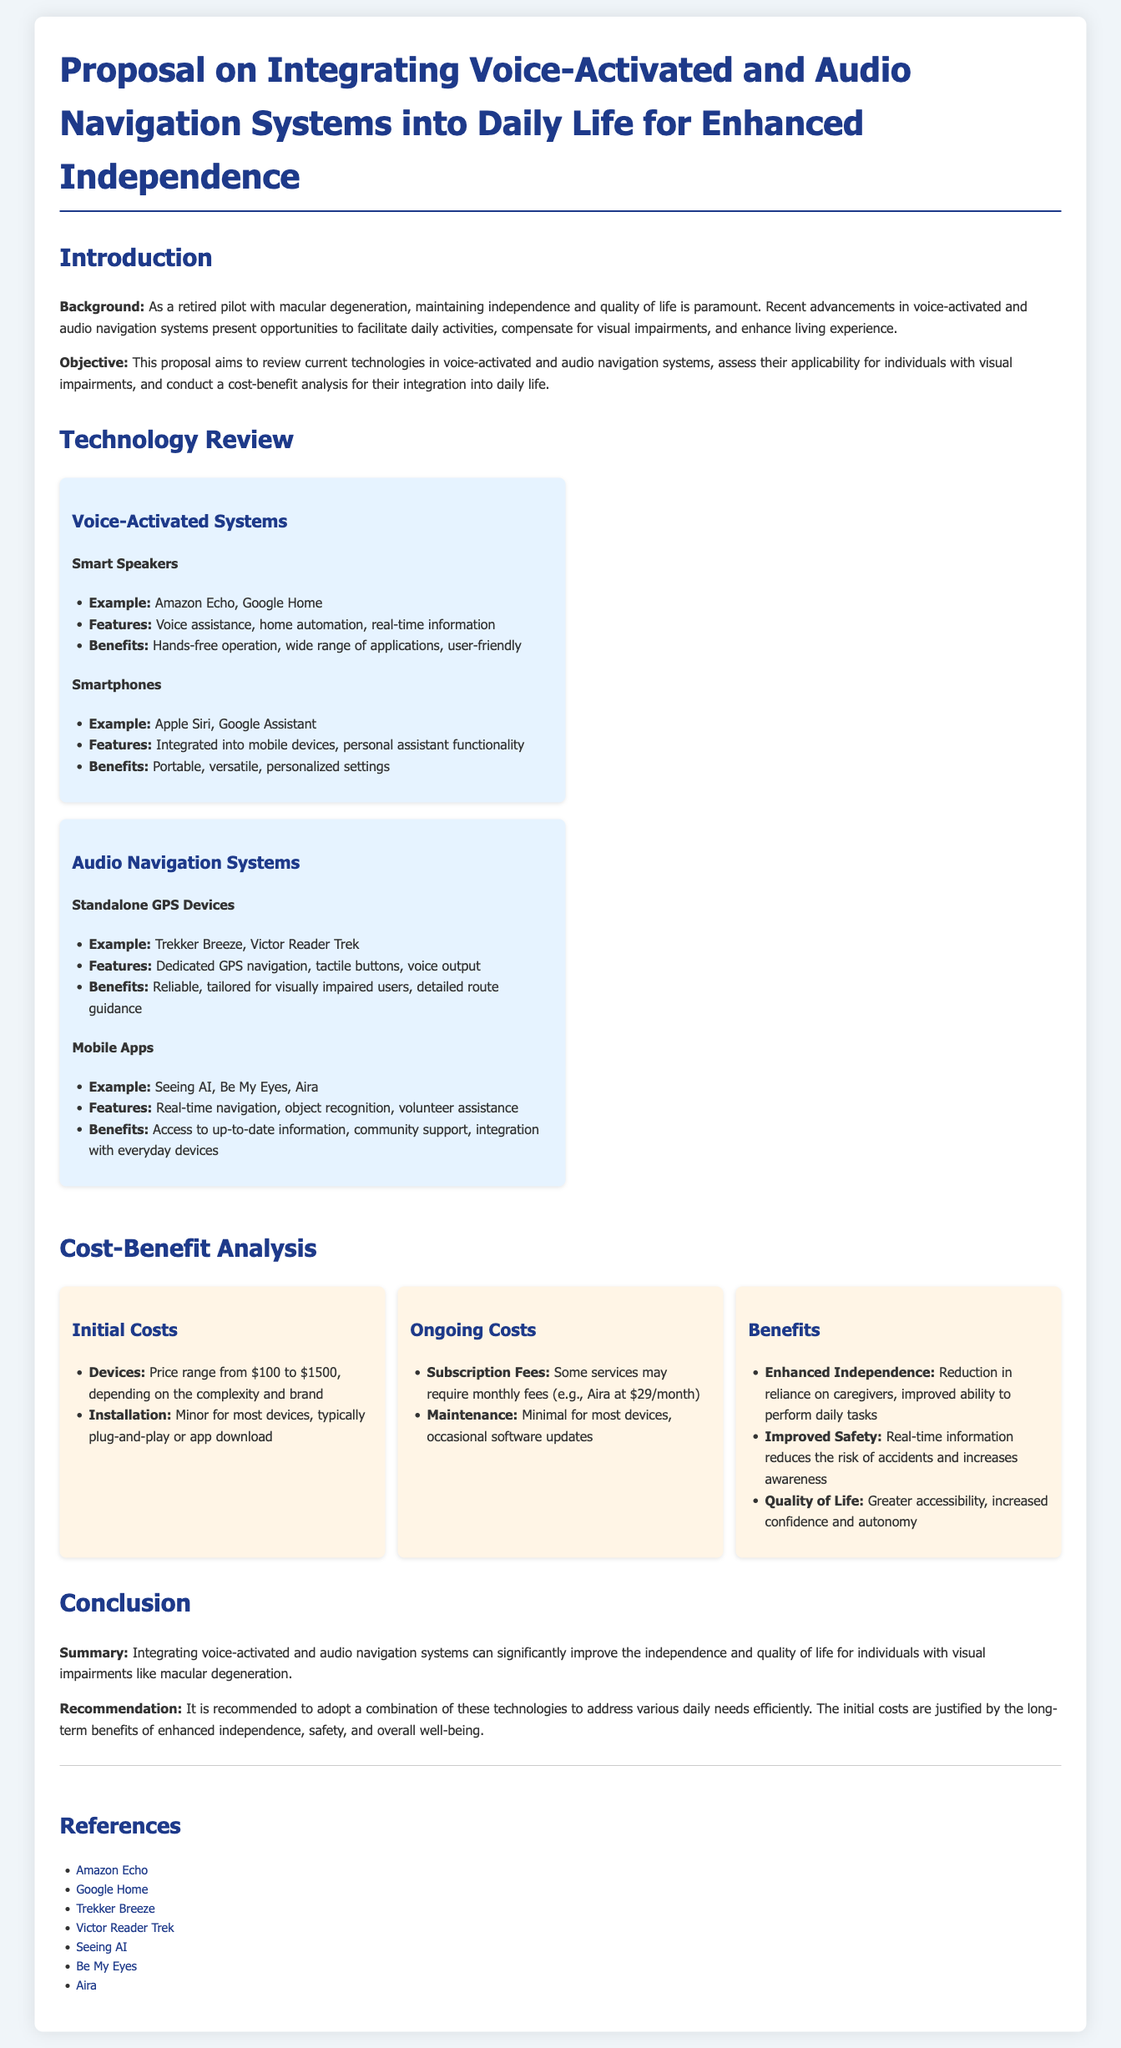What is the main objective of the proposal? The proposal aims to review current technologies in voice-activated and audio navigation systems, assess their applicability for individuals with visual impairments, and conduct a cost-benefit analysis for their integration into daily life.
Answer: Review technologies, assess applicability, conduct cost-benefit analysis What are two examples of voice-activated systems mentioned? The document lists examples of voice-activated systems, which include Amazon Echo and Google Home under smart speakers, and Apple Siri and Google Assistant under smartphones.
Answer: Amazon Echo, Google Home What is a benefit of audio navigation systems? The proposal outlines benefits of audio navigation systems, noting that they provide reliable and detailed route guidance tailored for visually impaired users.
Answer: Reliable, tailored guidance What is the price range for devices? This information is found under the cost-benefit analysis section, stating that devices range from $100 to $1500, depending on complexity and brand.
Answer: $100 to $1500 What is the ongoing subscription fee for Aira? The document specifies the subscription fee for Aira as $29 per month.
Answer: $29/month What is the recommendation for technology adoption? The document concludes with a recommendation to adopt a combination of these technologies to address various daily needs efficiently.
Answer: Adopt a combination What are the components of initial costs? The proposal identifies devices and installation as the components of initial costs, mentioning that the price depends on the complexity and brand, while installation is typically minor.
Answer: Devices, installation What are two benefits of integrating technology for individuals with visual impairments? The benefits include enhanced independence and improved safety, as mentioned in the cost-benefit analysis section.
Answer: Enhanced independence, improved safety 